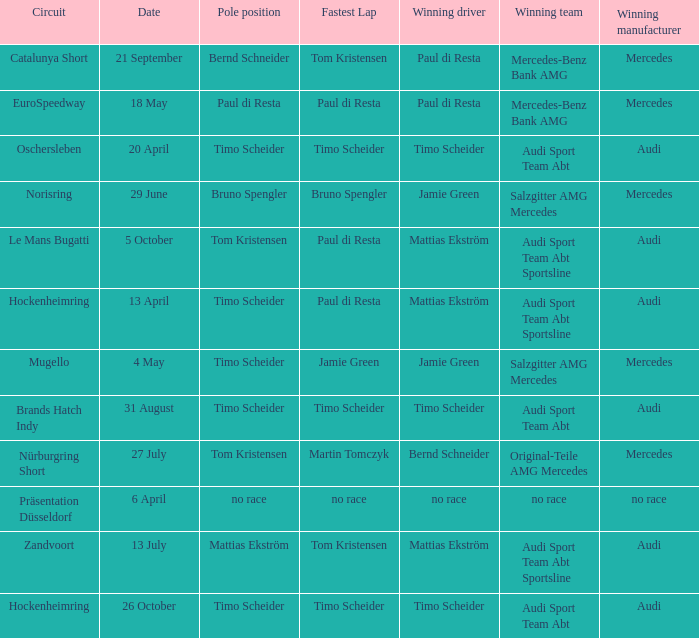What is the fastest lap in the Le Mans Bugatti circuit? Paul di Resta. 